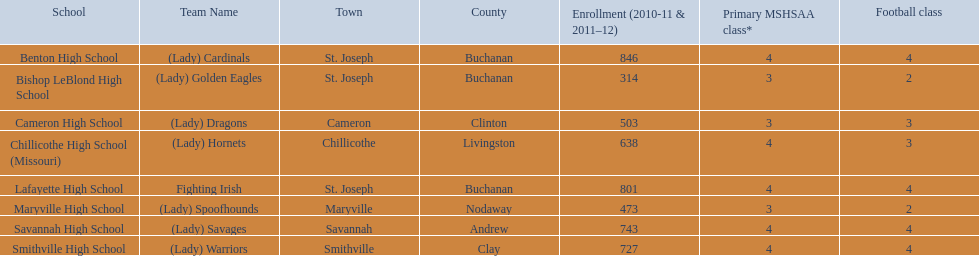How many teams are named after birds? 2. 